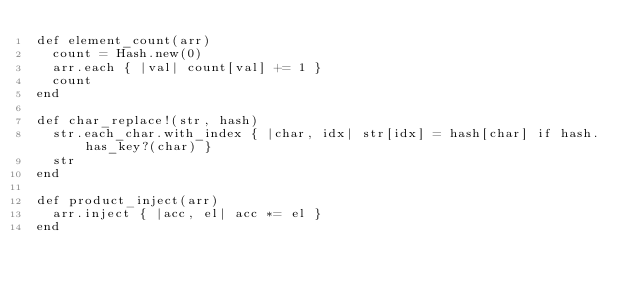<code> <loc_0><loc_0><loc_500><loc_500><_Ruby_>def element_count(arr)
  count = Hash.new(0)
  arr.each { |val| count[val] += 1 }
  count
end

def char_replace!(str, hash)
  str.each_char.with_index { |char, idx| str[idx] = hash[char] if hash.has_key?(char) }
  str
end

def product_inject(arr)
  arr.inject { |acc, el| acc *= el }
end</code> 